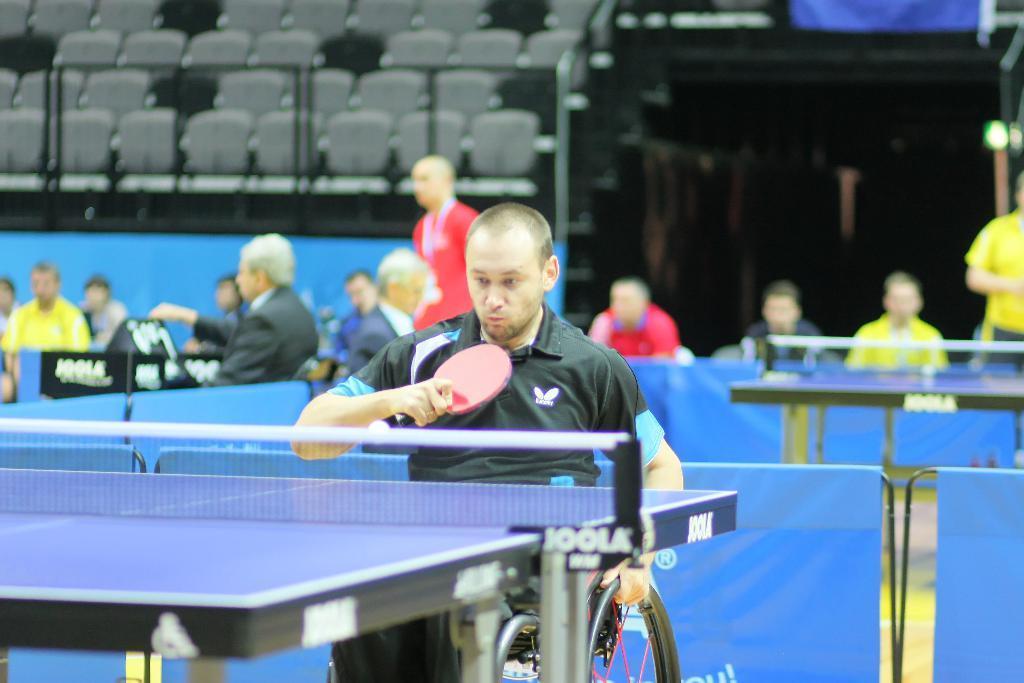Could you give a brief overview of what you see in this image? This image consists of Table Tennis boards. There is a person on wheelchair who is playing table tennis. There is a net in the middle. there are so many chairs on the top left corner. There are people in the middle who are standing. 